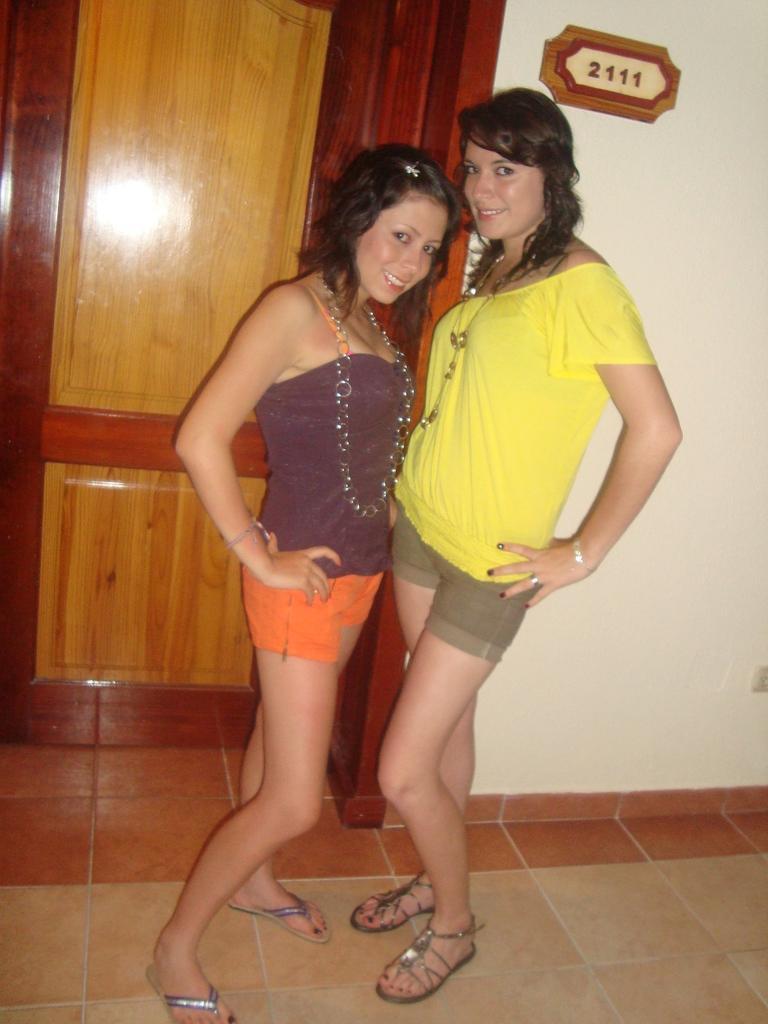Describe this image in one or two sentences. In this picture I can see two women are standing and smiling. In the background I can see a white color wall on which something attached to it. On the left side I can see a wooden door. 